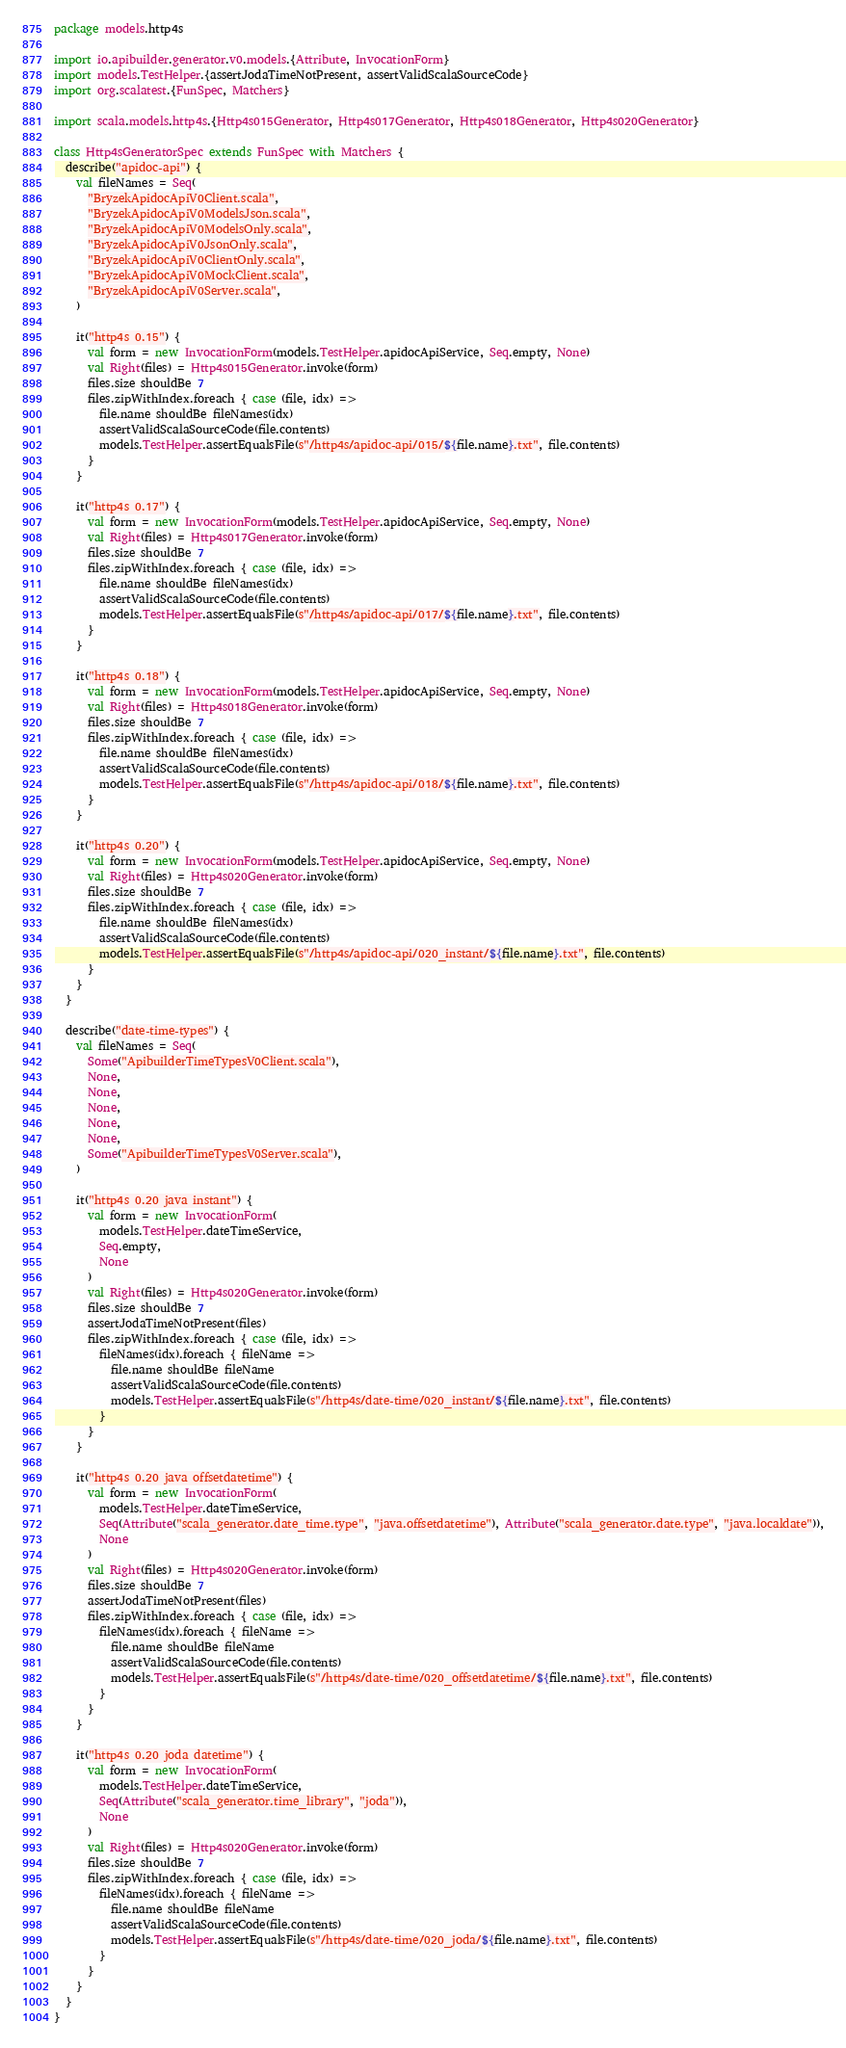<code> <loc_0><loc_0><loc_500><loc_500><_Scala_>package models.http4s

import io.apibuilder.generator.v0.models.{Attribute, InvocationForm}
import models.TestHelper.{assertJodaTimeNotPresent, assertValidScalaSourceCode}
import org.scalatest.{FunSpec, Matchers}

import scala.models.http4s.{Http4s015Generator, Http4s017Generator, Http4s018Generator, Http4s020Generator}

class Http4sGeneratorSpec extends FunSpec with Matchers {
  describe("apidoc-api") {
    val fileNames = Seq(
      "BryzekApidocApiV0Client.scala",
      "BryzekApidocApiV0ModelsJson.scala",
      "BryzekApidocApiV0ModelsOnly.scala",
      "BryzekApidocApiV0JsonOnly.scala",
      "BryzekApidocApiV0ClientOnly.scala",
      "BryzekApidocApiV0MockClient.scala",
      "BryzekApidocApiV0Server.scala",
    )

    it("http4s 0.15") {
      val form = new InvocationForm(models.TestHelper.apidocApiService, Seq.empty, None)
      val Right(files) = Http4s015Generator.invoke(form)
      files.size shouldBe 7
      files.zipWithIndex.foreach { case (file, idx) =>
        file.name shouldBe fileNames(idx)
        assertValidScalaSourceCode(file.contents)
        models.TestHelper.assertEqualsFile(s"/http4s/apidoc-api/015/${file.name}.txt", file.contents)
      }
    }

    it("http4s 0.17") {
      val form = new InvocationForm(models.TestHelper.apidocApiService, Seq.empty, None)
      val Right(files) = Http4s017Generator.invoke(form)
      files.size shouldBe 7
      files.zipWithIndex.foreach { case (file, idx) =>
        file.name shouldBe fileNames(idx)
        assertValidScalaSourceCode(file.contents)
        models.TestHelper.assertEqualsFile(s"/http4s/apidoc-api/017/${file.name}.txt", file.contents)
      }
    }

    it("http4s 0.18") {
      val form = new InvocationForm(models.TestHelper.apidocApiService, Seq.empty, None)
      val Right(files) = Http4s018Generator.invoke(form)
      files.size shouldBe 7
      files.zipWithIndex.foreach { case (file, idx) =>
        file.name shouldBe fileNames(idx)
        assertValidScalaSourceCode(file.contents)
        models.TestHelper.assertEqualsFile(s"/http4s/apidoc-api/018/${file.name}.txt", file.contents)
      }
    }

    it("http4s 0.20") {
      val form = new InvocationForm(models.TestHelper.apidocApiService, Seq.empty, None)
      val Right(files) = Http4s020Generator.invoke(form)
      files.size shouldBe 7
      files.zipWithIndex.foreach { case (file, idx) =>
        file.name shouldBe fileNames(idx)
        assertValidScalaSourceCode(file.contents)
        models.TestHelper.assertEqualsFile(s"/http4s/apidoc-api/020_instant/${file.name}.txt", file.contents)
      }
    }
  }

  describe("date-time-types") {
    val fileNames = Seq(
      Some("ApibuilderTimeTypesV0Client.scala"),
      None,
      None,
      None,
      None,
      None,
      Some("ApibuilderTimeTypesV0Server.scala"),
    )

    it("http4s 0.20 java instant") {
      val form = new InvocationForm(
        models.TestHelper.dateTimeService,
        Seq.empty,
        None
      )
      val Right(files) = Http4s020Generator.invoke(form)
      files.size shouldBe 7
      assertJodaTimeNotPresent(files)
      files.zipWithIndex.foreach { case (file, idx) =>
        fileNames(idx).foreach { fileName =>
          file.name shouldBe fileName
          assertValidScalaSourceCode(file.contents)
          models.TestHelper.assertEqualsFile(s"/http4s/date-time/020_instant/${file.name}.txt", file.contents)
        }
      }
    }

    it("http4s 0.20 java offsetdatetime") {
      val form = new InvocationForm(
        models.TestHelper.dateTimeService,
        Seq(Attribute("scala_generator.date_time.type", "java.offsetdatetime"), Attribute("scala_generator.date.type", "java.localdate")),
        None
      )
      val Right(files) = Http4s020Generator.invoke(form)
      files.size shouldBe 7
      assertJodaTimeNotPresent(files)
      files.zipWithIndex.foreach { case (file, idx) =>
        fileNames(idx).foreach { fileName =>
          file.name shouldBe fileName
          assertValidScalaSourceCode(file.contents)
          models.TestHelper.assertEqualsFile(s"/http4s/date-time/020_offsetdatetime/${file.name}.txt", file.contents)
        }
      }
    }

    it("http4s 0.20 joda datetime") {
      val form = new InvocationForm(
        models.TestHelper.dateTimeService,
        Seq(Attribute("scala_generator.time_library", "joda")),
        None
      )
      val Right(files) = Http4s020Generator.invoke(form)
      files.size shouldBe 7
      files.zipWithIndex.foreach { case (file, idx) =>
        fileNames(idx).foreach { fileName =>
          file.name shouldBe fileName
          assertValidScalaSourceCode(file.contents)
          models.TestHelper.assertEqualsFile(s"/http4s/date-time/020_joda/${file.name}.txt", file.contents)
        }
      }
    }
  }
}
</code> 